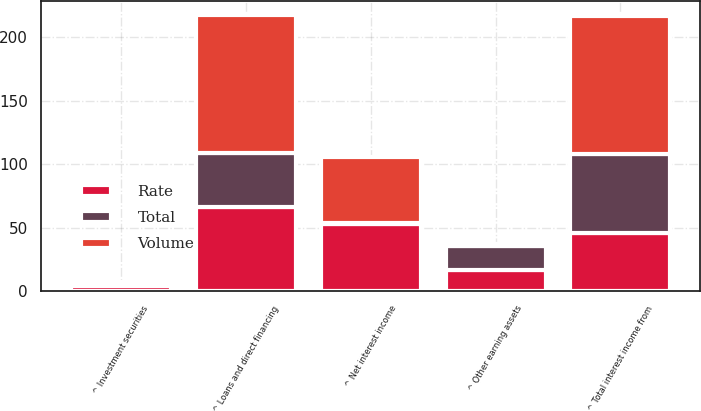Convert chart. <chart><loc_0><loc_0><loc_500><loc_500><stacked_bar_chart><ecel><fcel>^ Loans and direct financing<fcel>^ Investment securities<fcel>^ Other earning assets<fcel>^ Total interest income from<fcel>^ Net interest income<nl><fcel>Rate<fcel>66.1<fcel>3.7<fcel>16.8<fcel>45.6<fcel>52.8<nl><fcel>Volume<fcel>108.7<fcel>2<fcel>1.7<fcel>108.4<fcel>51.8<nl><fcel>Total<fcel>42.6<fcel>1.7<fcel>18.5<fcel>62.8<fcel>1<nl></chart> 